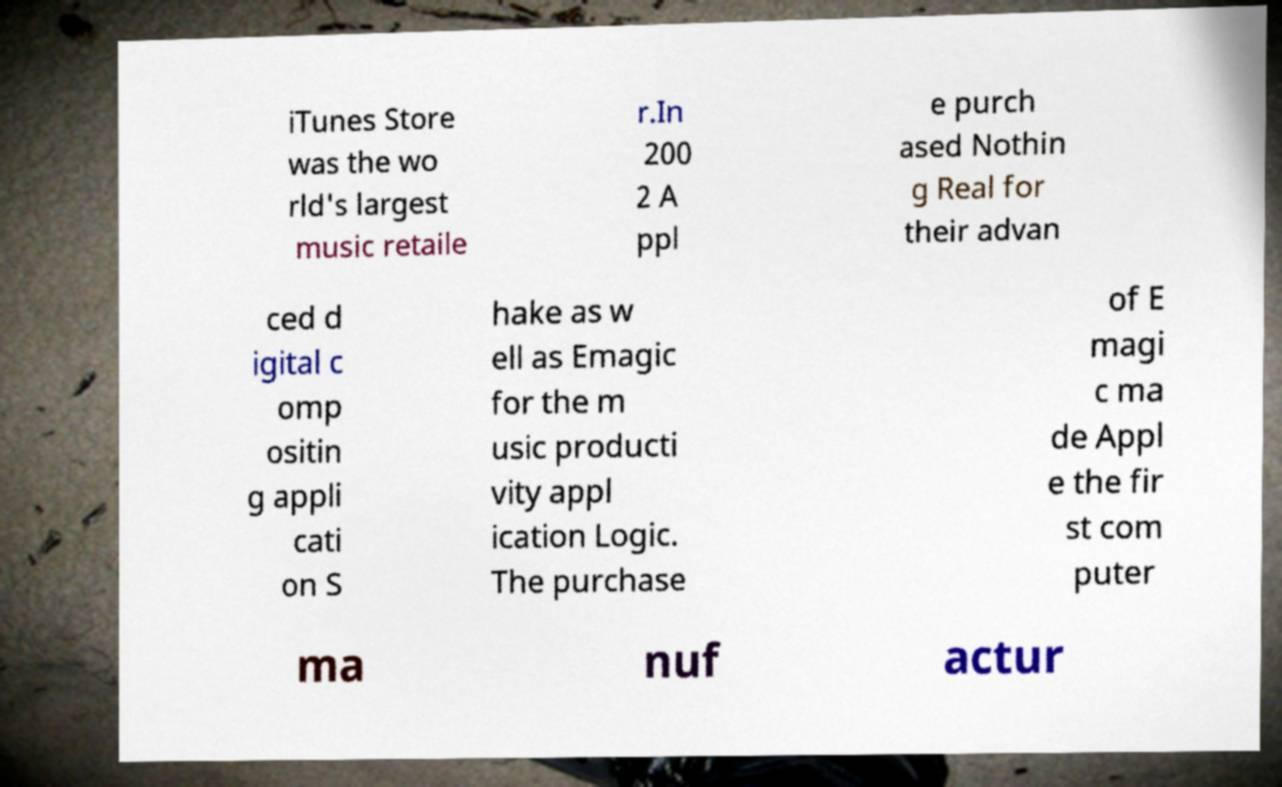Please identify and transcribe the text found in this image. iTunes Store was the wo rld's largest music retaile r.In 200 2 A ppl e purch ased Nothin g Real for their advan ced d igital c omp ositin g appli cati on S hake as w ell as Emagic for the m usic producti vity appl ication Logic. The purchase of E magi c ma de Appl e the fir st com puter ma nuf actur 